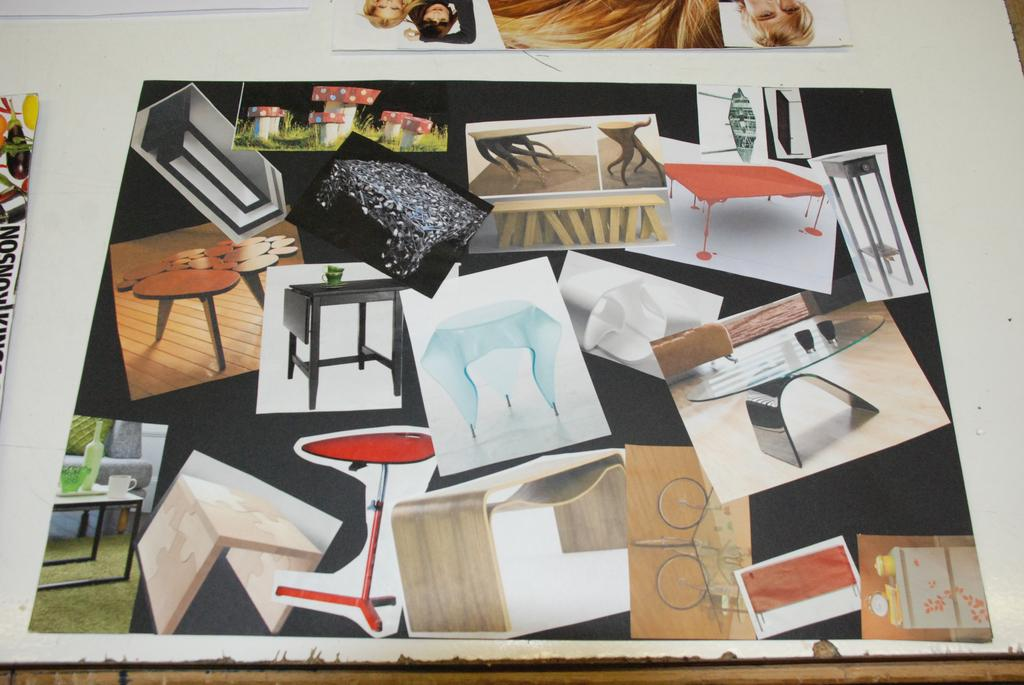What is the main subject of the photos in the image? The main subject of the photos in the image is tables. Where are the photos of tables located in the image? The photos of tables are placed on a table. What type of beetle can be seen crawling on the caption of the photos in the image? There is no beetle present in the image, and there is no caption associated with the photos. 